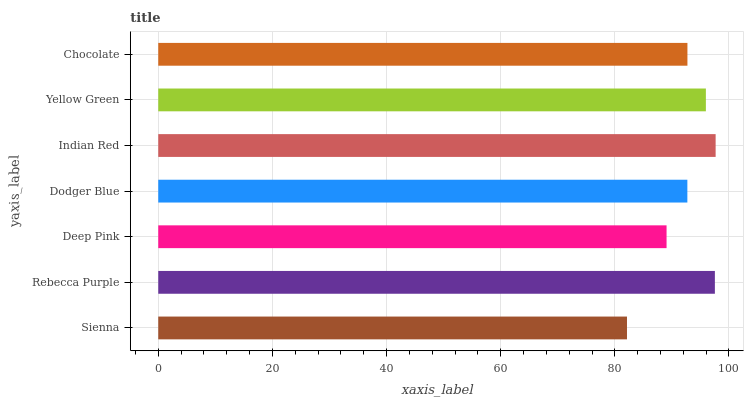Is Sienna the minimum?
Answer yes or no. Yes. Is Indian Red the maximum?
Answer yes or no. Yes. Is Rebecca Purple the minimum?
Answer yes or no. No. Is Rebecca Purple the maximum?
Answer yes or no. No. Is Rebecca Purple greater than Sienna?
Answer yes or no. Yes. Is Sienna less than Rebecca Purple?
Answer yes or no. Yes. Is Sienna greater than Rebecca Purple?
Answer yes or no. No. Is Rebecca Purple less than Sienna?
Answer yes or no. No. Is Chocolate the high median?
Answer yes or no. Yes. Is Chocolate the low median?
Answer yes or no. Yes. Is Rebecca Purple the high median?
Answer yes or no. No. Is Yellow Green the low median?
Answer yes or no. No. 